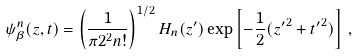<formula> <loc_0><loc_0><loc_500><loc_500>\psi ^ { n } _ { \beta } ( z , t ) = \left ( \frac { 1 } { \pi 2 ^ { 2 } n ! } \right ) ^ { 1 / 2 } H _ { n } ( z ^ { \prime } ) \exp \left [ - \frac { 1 } { 2 } ( { z ^ { \prime } } ^ { 2 } + { t ^ { \prime } } ^ { 2 } ) \right ] \, ,</formula> 